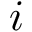<formula> <loc_0><loc_0><loc_500><loc_500>i</formula> 